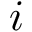<formula> <loc_0><loc_0><loc_500><loc_500>i</formula> 